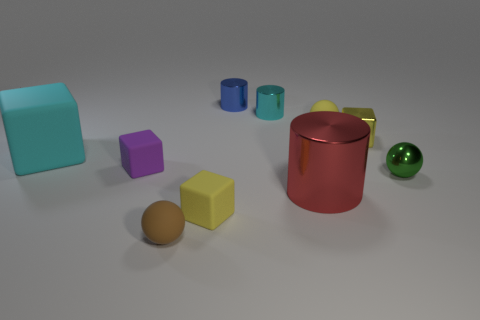Are there any yellow matte cubes that have the same size as the blue metal cylinder?
Give a very brief answer. Yes. There is a tiny yellow rubber thing that is in front of the big cyan matte block; is its shape the same as the blue object?
Your answer should be compact. No. Is the shape of the blue thing the same as the small brown rubber thing?
Your response must be concise. No. Is there a large cyan rubber thing that has the same shape as the brown thing?
Offer a very short reply. No. What is the shape of the tiny rubber object that is to the right of the cyan object on the right side of the cyan block?
Offer a very short reply. Sphere. What color is the small cube to the left of the brown rubber ball?
Offer a very short reply. Purple. There is a purple block that is made of the same material as the cyan block; what is its size?
Your answer should be compact. Small. There is a brown rubber thing that is the same shape as the tiny green object; what size is it?
Ensure brevity in your answer.  Small. Are any cubes visible?
Your answer should be compact. Yes. How many objects are either small yellow shiny things in front of the tiny blue shiny object or brown rubber blocks?
Offer a very short reply. 1. 